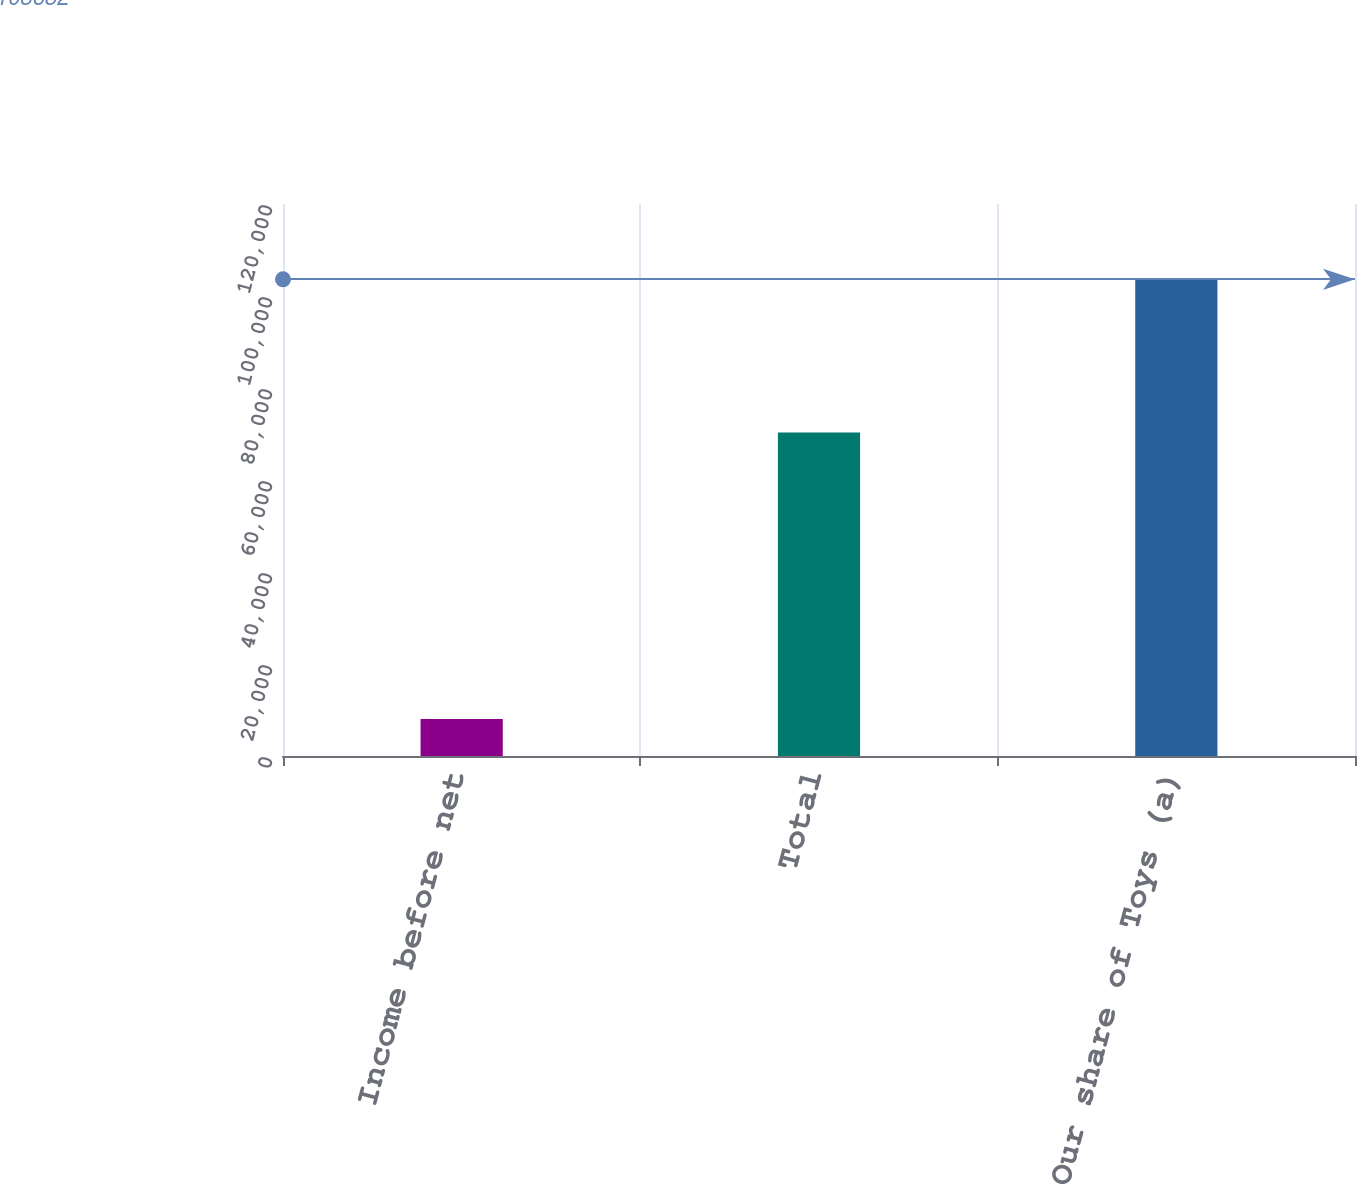Convert chart to OTSL. <chart><loc_0><loc_0><loc_500><loc_500><bar_chart><fcel>Income before net<fcel>Total<fcel>Our share of Toys (a)<nl><fcel>8056<fcel>70306<fcel>103632<nl></chart> 